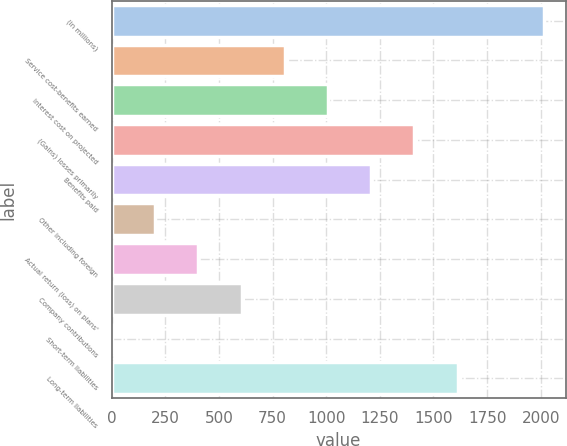Convert chart. <chart><loc_0><loc_0><loc_500><loc_500><bar_chart><fcel>(in millions)<fcel>Service cost-benefits earned<fcel>Interest cost on projected<fcel>(Gains) losses primarily<fcel>Benefits paid<fcel>Other including foreign<fcel>Actual return (loss) on plans'<fcel>Company contributions<fcel>Short-term liabilities<fcel>Long-term liabilities<nl><fcel>2015<fcel>806.6<fcel>1008<fcel>1410.8<fcel>1209.4<fcel>202.4<fcel>403.8<fcel>605.2<fcel>1<fcel>1612.2<nl></chart> 